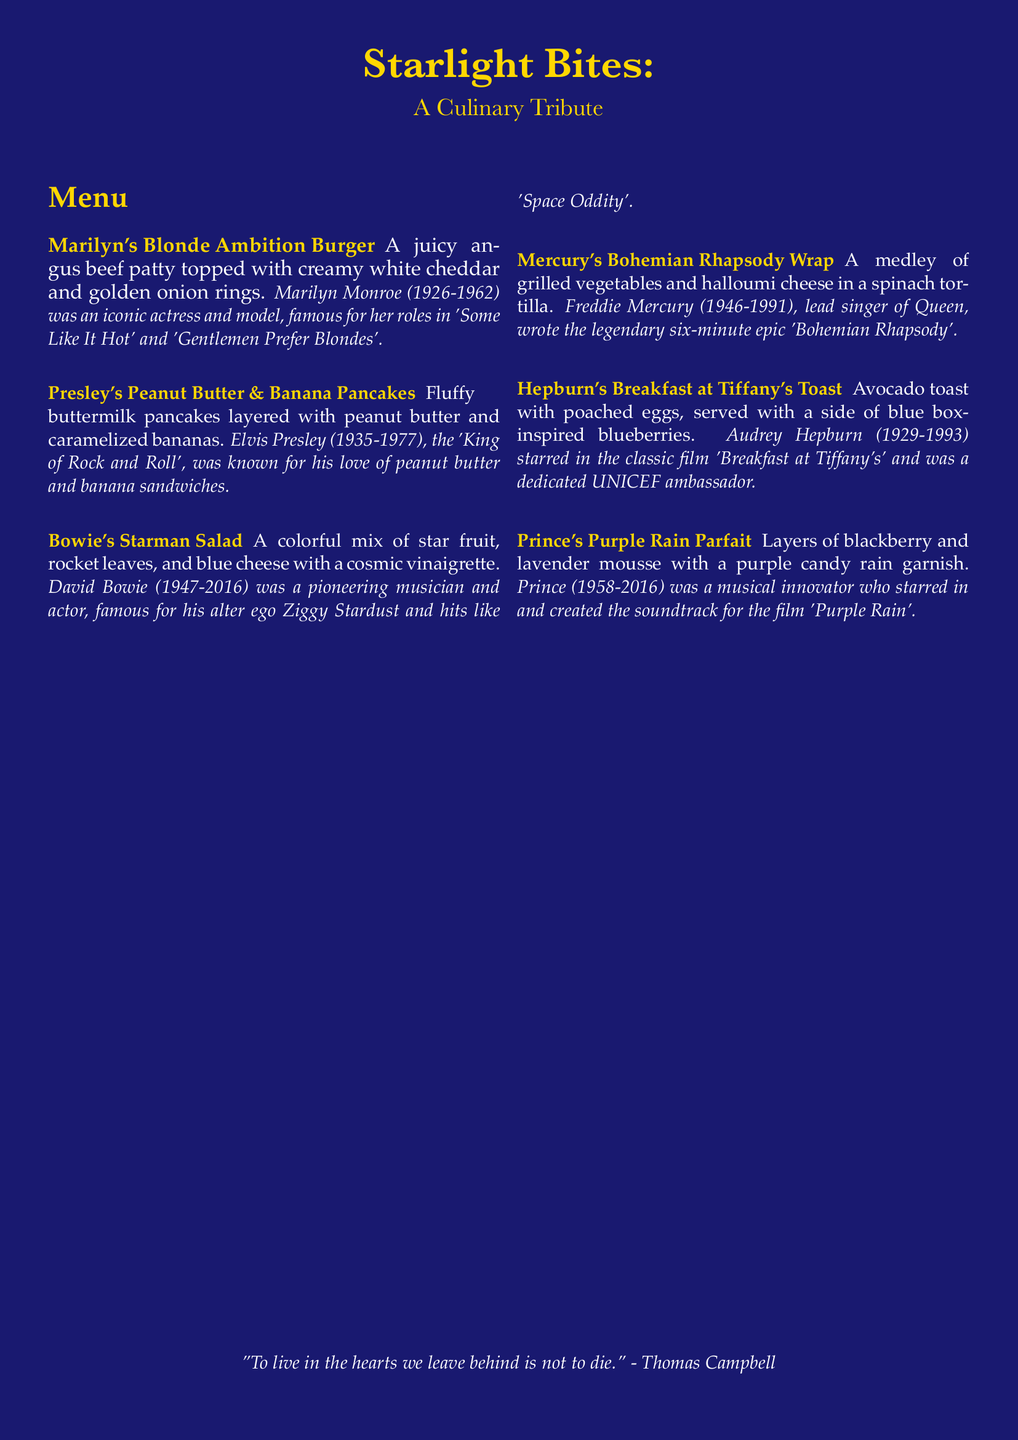What is the name of the burger item? The burger item listed on the menu is specifically called "Marilyn's Blonde Ambition Burger".
Answer: Marilyn's Blonde Ambition Burger Who is the burger inspired by? The burger is inspired by Marilyn Monroe, an iconic actress and model.
Answer: Marilyn Monroe What type of cheese is used in the Bohemian Rhapsody Wrap? The wrap features halloumi cheese as one of its ingredients.
Answer: Halloumi cheese How many dishes are listed on the menu? The menu includes a total of five dishes presented for the guests.
Answer: Five Which dish is inspired by a musician known for their love of peanut butter and banana sandwiches? The dish that references this preference is "Presley's Peanut Butter & Banana Pancakes".
Answer: Presley's Peanut Butter & Banana Pancakes What fruit is included in Bowie's Starman Salad? The salad features star fruit as a primary ingredient among others.
Answer: Star fruit What is the flavor profile of Prince's Purple Rain Parfait? The parfait is characterized by layers of blackberry and lavender mousse.
Answer: Blackberry and lavender mousse What quote is at the bottom of the menu? The menu concludes with a quote by Thomas Campbell regarding remembrance.
Answer: "To live in the hearts we leave behind is not to die." Which actress starred in 'Breakfast at Tiffany's'? Audrey Hepburn is recognized for her role in this classic film.
Answer: Audrey Hepburn 